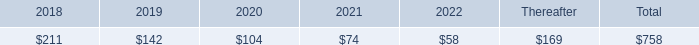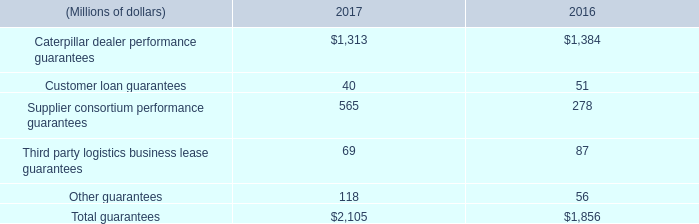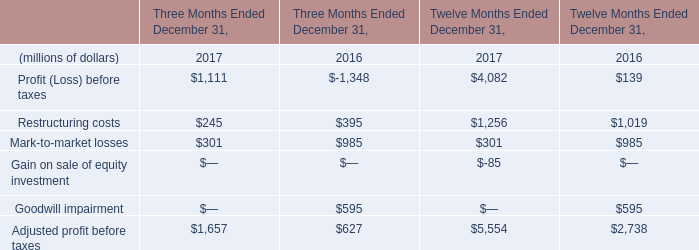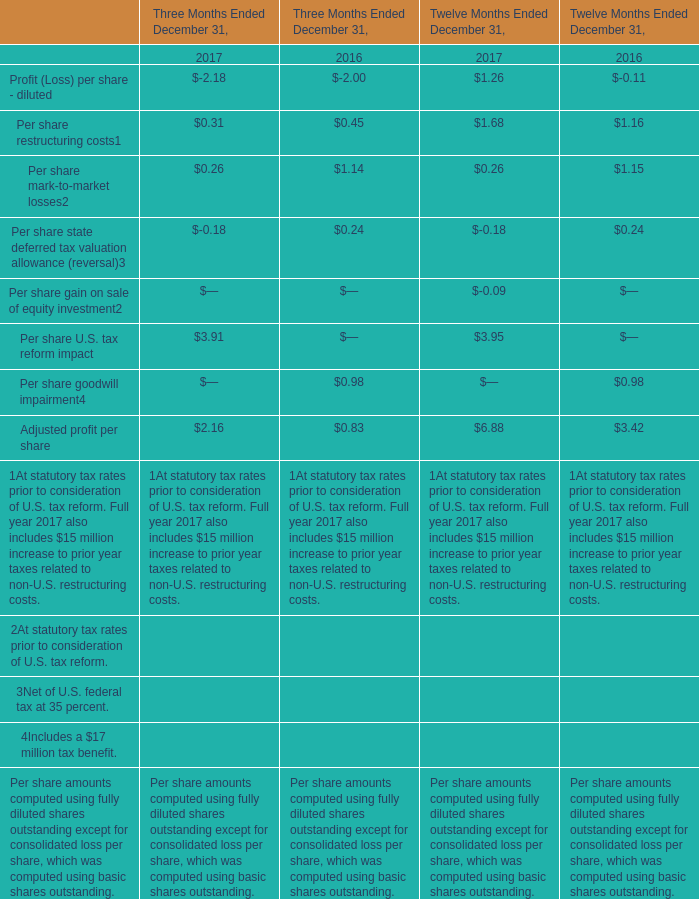how many countries are cat products distributed to? 
Computations: (192 + 1)
Answer: 193.0. 